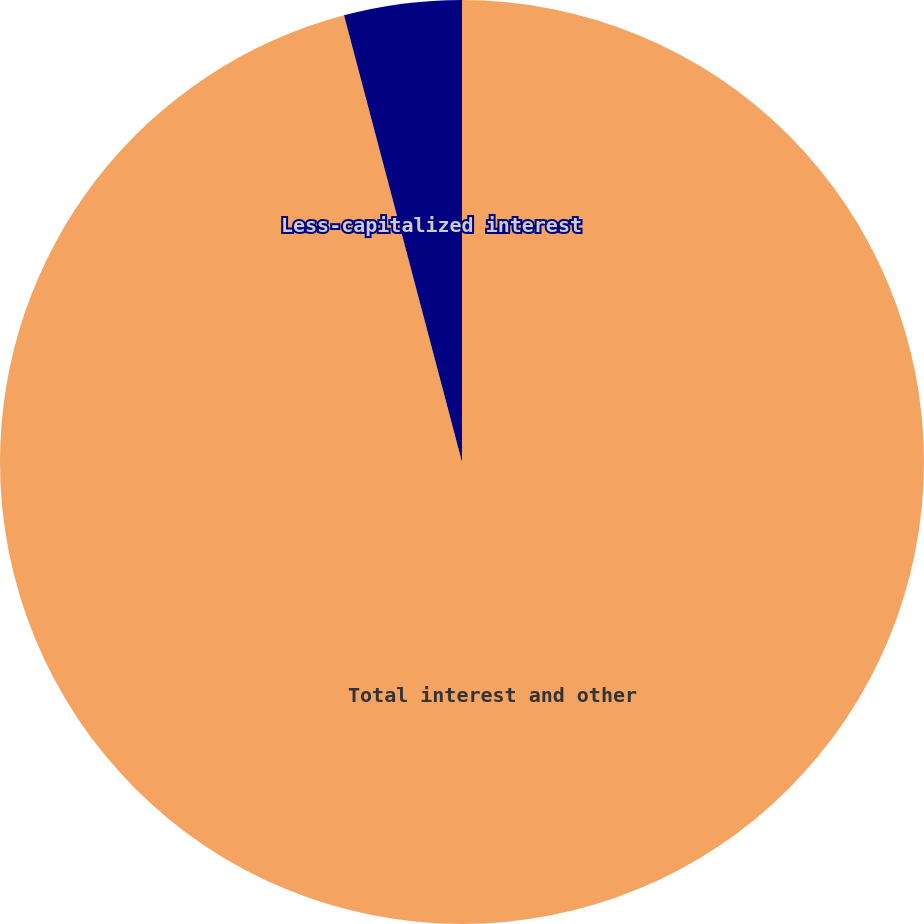<chart> <loc_0><loc_0><loc_500><loc_500><pie_chart><fcel>Total interest and other<fcel>Less-capitalized interest<nl><fcel>95.89%<fcel>4.11%<nl></chart> 